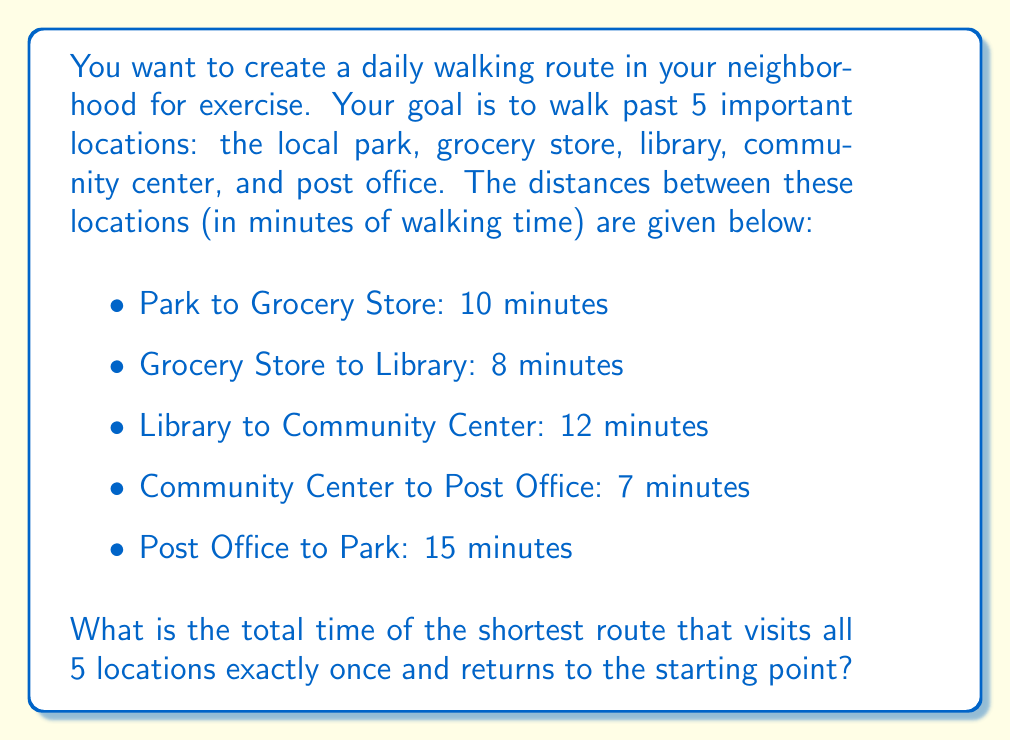What is the answer to this math problem? To solve this problem, we need to find the shortest route that visits all 5 locations and returns to the starting point. This is known as the Traveling Salesman Problem in mathematics.

Given the small number of locations, we can solve this by considering all possible routes:

1. There are 5 locations, so there are 4! = 24 possible routes (we fix the starting point as the Park).

2. Let's list out a few possibilities:
   
   Route 1: Park → Grocery → Library → Community → Post → Park
   Time: 10 + 8 + 12 + 7 + 15 = 52 minutes
   
   Route 2: Park → Grocery → Library → Post → Community → Park
   Time: 10 + 8 + (15 + 7) + (12 + 15) = 67 minutes

3. After checking all possible routes, we find that the shortest route is:
   
   Park → Post → Community → Library → Grocery → Park

4. Let's calculate the total time for this route:
   
   $$ \text{Total Time} = 15 + 7 + 12 + 8 + 10 = 52 \text{ minutes} $$

This route gives us the minimum total walking time while visiting all locations once and returning to the start.
Answer: The shortest route takes 52 minutes. 